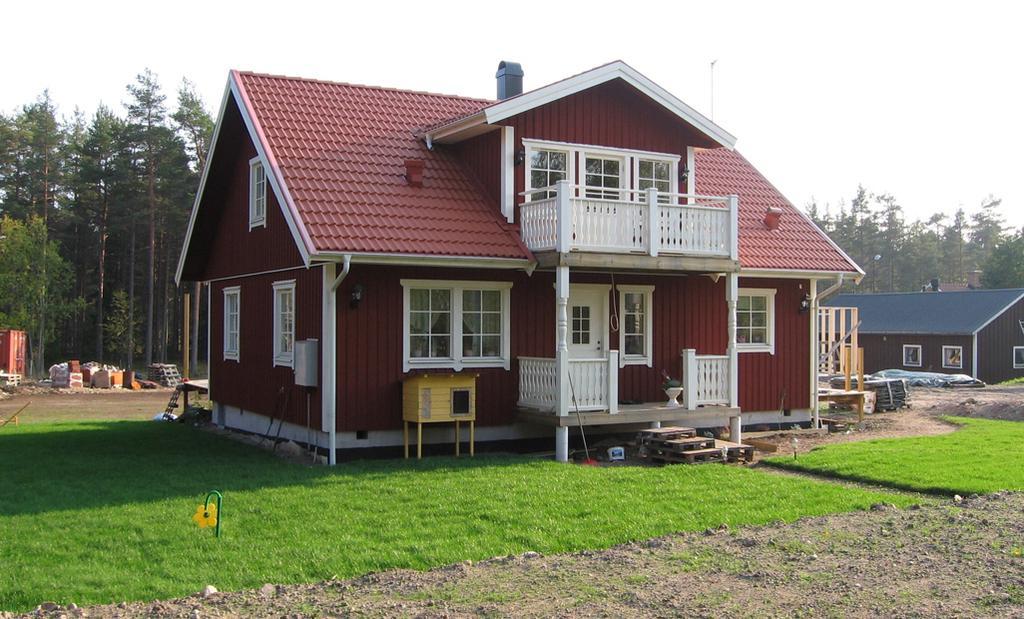In one or two sentences, can you explain what this image depicts? This is grass. Here we can see houses. In the background there are trees and sky. 